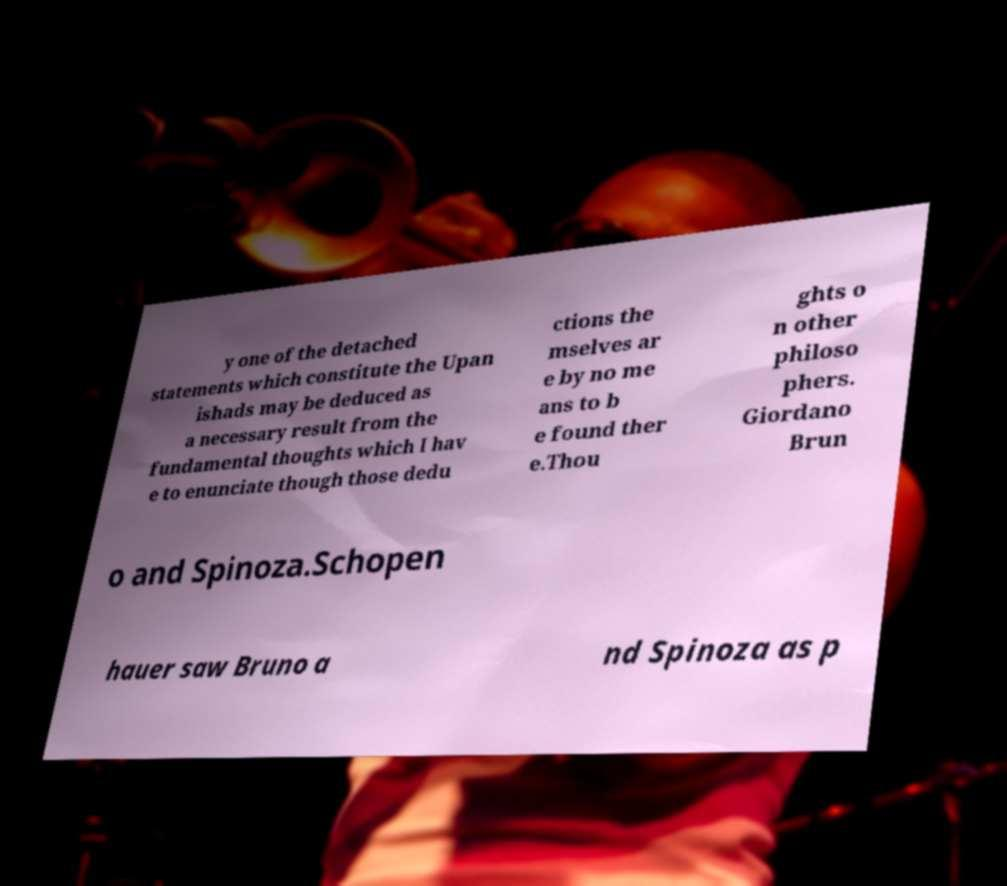What messages or text are displayed in this image? I need them in a readable, typed format. y one of the detached statements which constitute the Upan ishads may be deduced as a necessary result from the fundamental thoughts which I hav e to enunciate though those dedu ctions the mselves ar e by no me ans to b e found ther e.Thou ghts o n other philoso phers. Giordano Brun o and Spinoza.Schopen hauer saw Bruno a nd Spinoza as p 